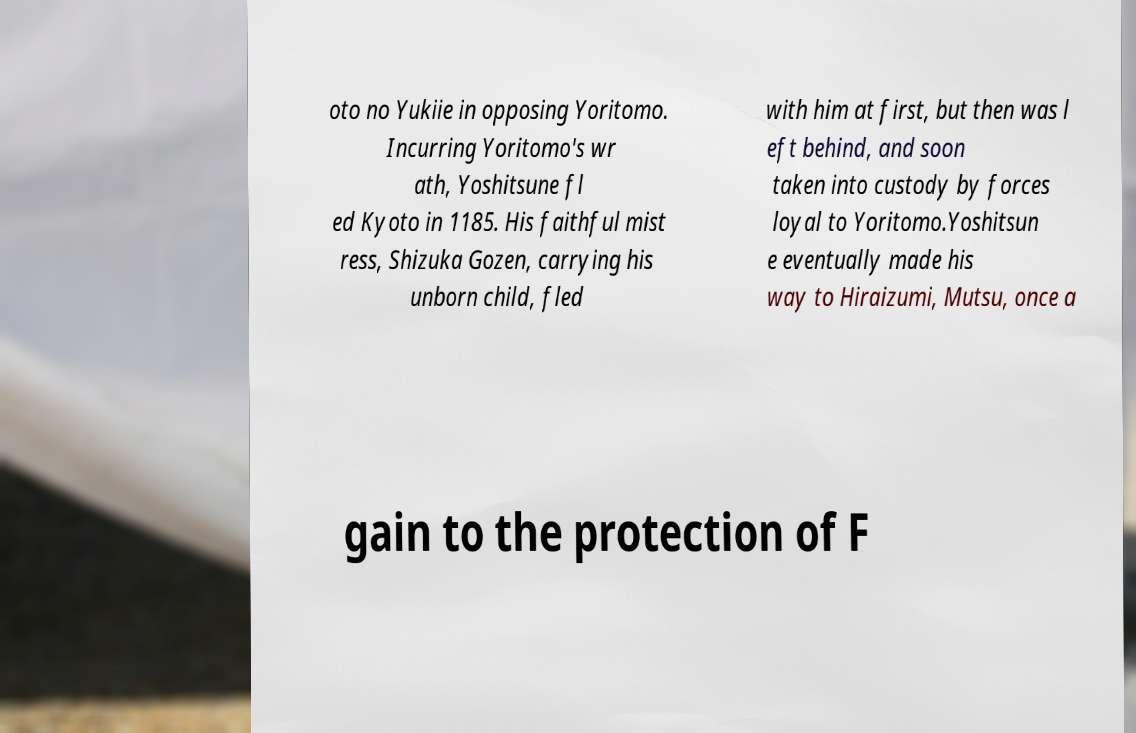Can you read and provide the text displayed in the image?This photo seems to have some interesting text. Can you extract and type it out for me? oto no Yukiie in opposing Yoritomo. Incurring Yoritomo's wr ath, Yoshitsune fl ed Kyoto in 1185. His faithful mist ress, Shizuka Gozen, carrying his unborn child, fled with him at first, but then was l eft behind, and soon taken into custody by forces loyal to Yoritomo.Yoshitsun e eventually made his way to Hiraizumi, Mutsu, once a gain to the protection of F 